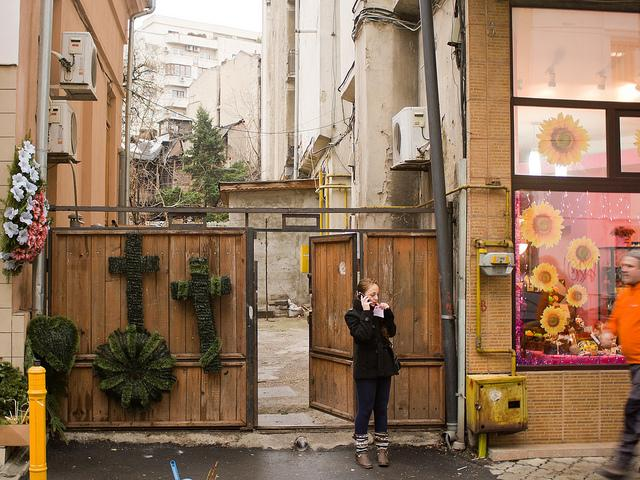What shape are two of the grass wreaths fashioned into?

Choices:
A) octagon
B) rectangle
C) tree
D) cross cross 